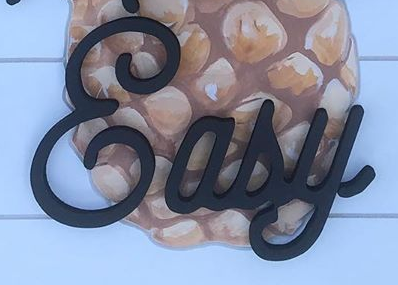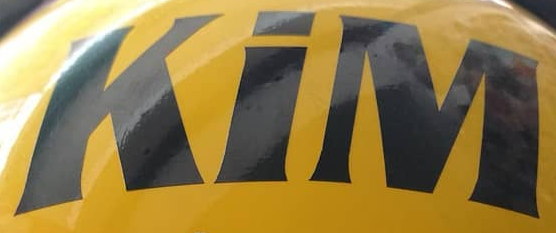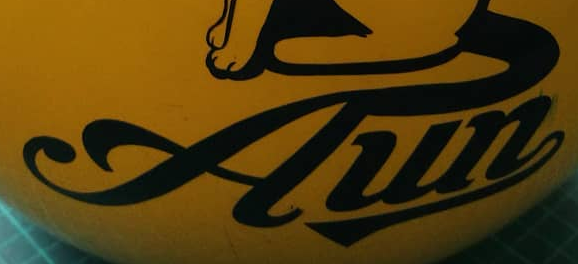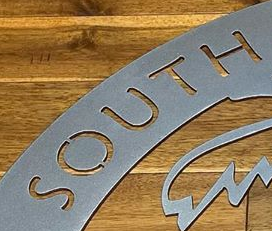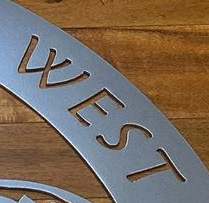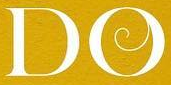What words can you see in these images in sequence, separated by a semicolon? &asy; KiM; Aun; SOUTH; WEST; DO 